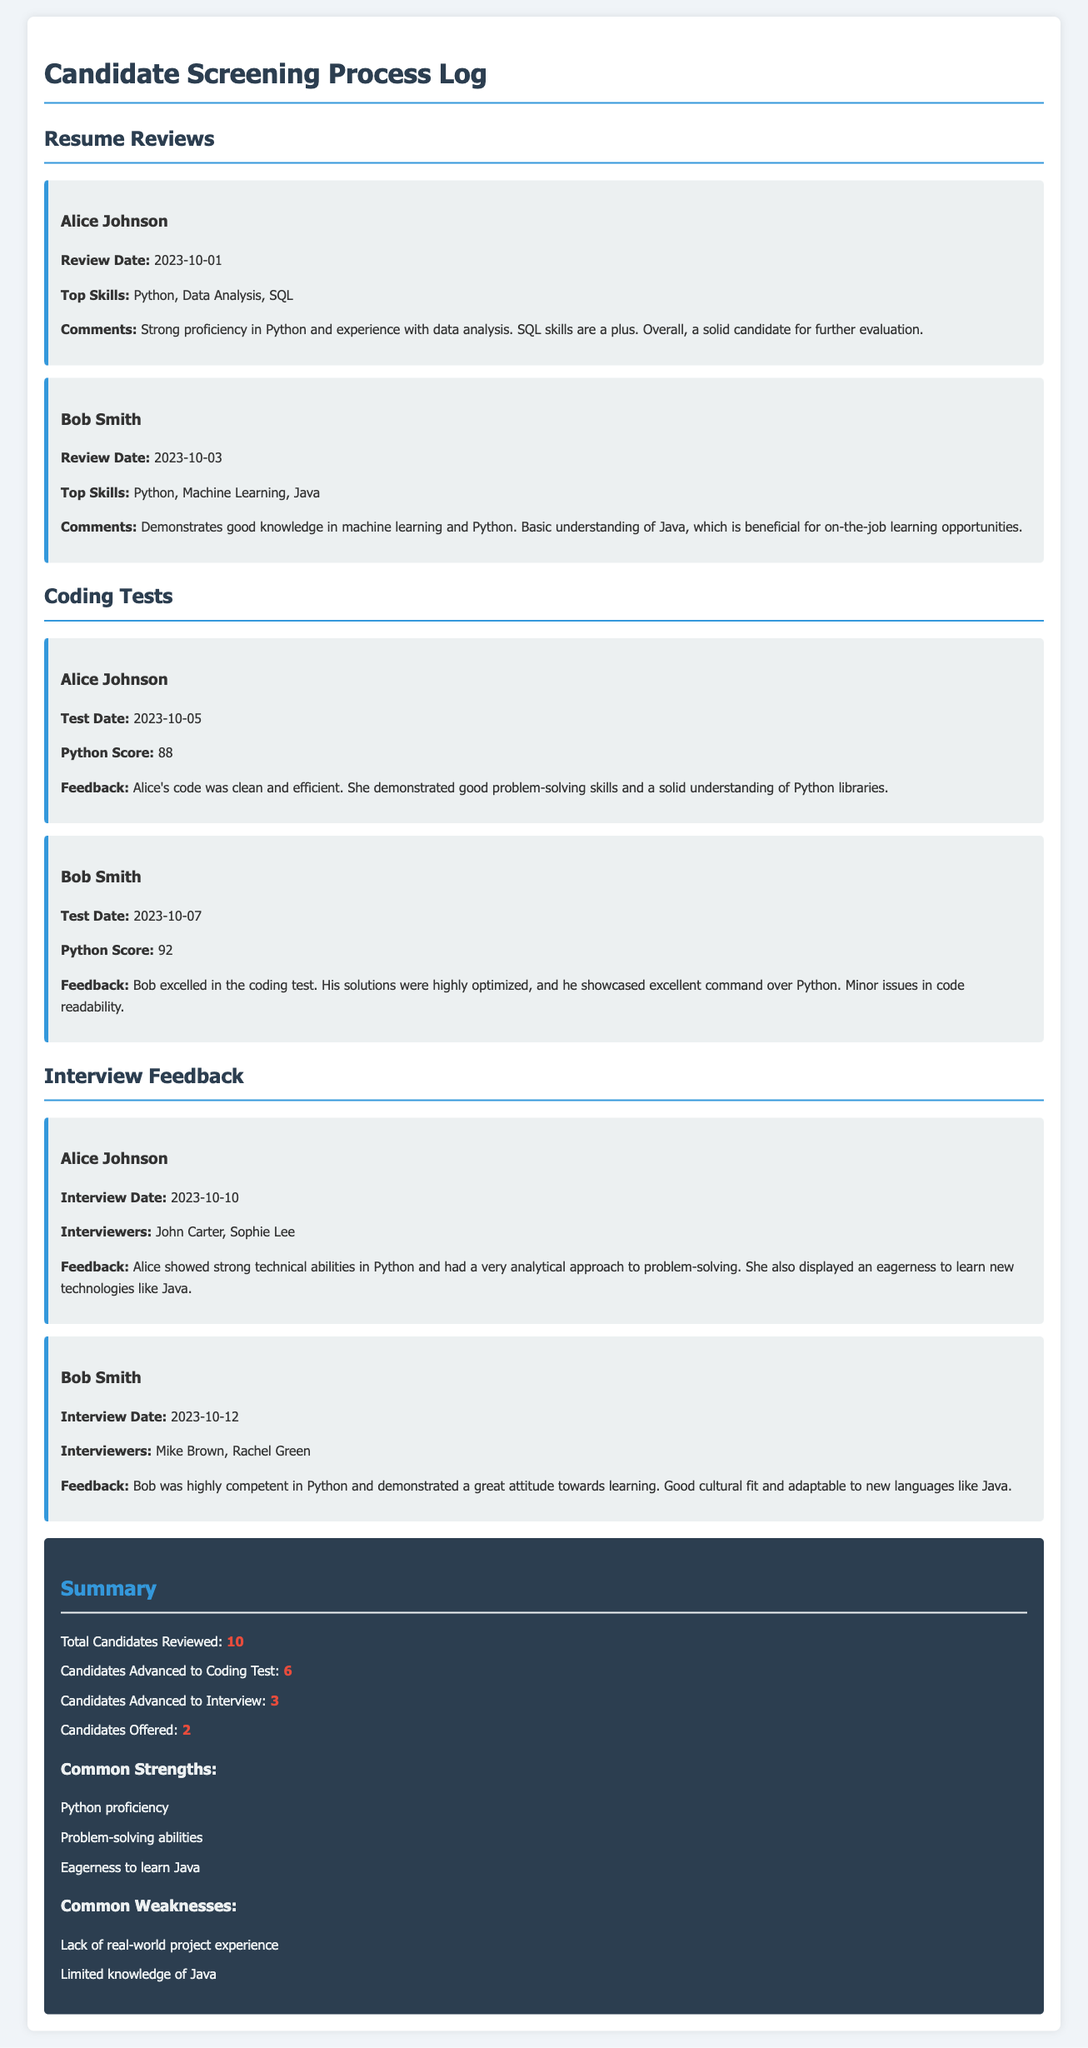What is the date of Alice Johnson's coding test? Alice Johnson's coding test date is specifically mentioned in the document.
Answer: 2023-10-05 What Python score did Bob Smith achieve in his coding test? The document lists Bob Smith's Python score directly in the coding test section.
Answer: 92 Who were the interviewers for Alice Johnson? The names of the interviewers for Alice Johnson are available in the interview feedback summary.
Answer: John Carter, Sophie Lee How many candidates advanced to interviews? The summary provides a specific number regarding candidates who moved on to the interview phase.
Answer: 3 What common strength is mentioned for candidates? The document lists strengths observed among candidates, specifically in one of the summary sections.
Answer: Python proficiency What is the top skill mentioned for Bob Smith? The document highlights Bob Smith's top skills during the resume review.
Answer: Python, Machine Learning, Java Which candidate had the highest coding test score? Comparing the provided coding test scores leads to identifying the candidate with the highest score.
Answer: Bob Smith What was a common weakness among candidates? The document notes weaknesses that were frequently observed in the candidates during the screening process.
Answer: Limited knowledge of Java 